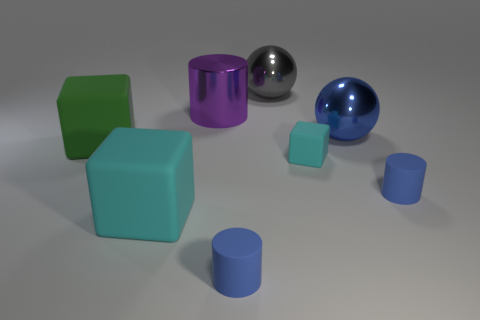What color is the tiny object that is the same shape as the big cyan rubber object?
Your answer should be compact. Cyan. There is a blue object that is left of the large ball that is behind the purple cylinder; what is its shape?
Keep it short and to the point. Cylinder. There is a small blue object that is to the right of the tiny cube; what shape is it?
Keep it short and to the point. Cylinder. What number of other cubes are the same color as the small block?
Make the answer very short. 1. The large cylinder is what color?
Your answer should be very brief. Purple. What number of blue matte cylinders are on the right side of the large matte cube that is in front of the green matte thing?
Your response must be concise. 2. Does the blue shiny thing have the same size as the cyan cube that is in front of the tiny cyan cube?
Keep it short and to the point. Yes. Do the purple cylinder and the green block have the same size?
Give a very brief answer. Yes. Is there a shiny cylinder of the same size as the green cube?
Your answer should be compact. Yes. There is a small blue thing that is on the right side of the gray thing; what is it made of?
Give a very brief answer. Rubber. 